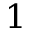Convert formula to latex. <formula><loc_0><loc_0><loc_500><loc_500>1</formula> 